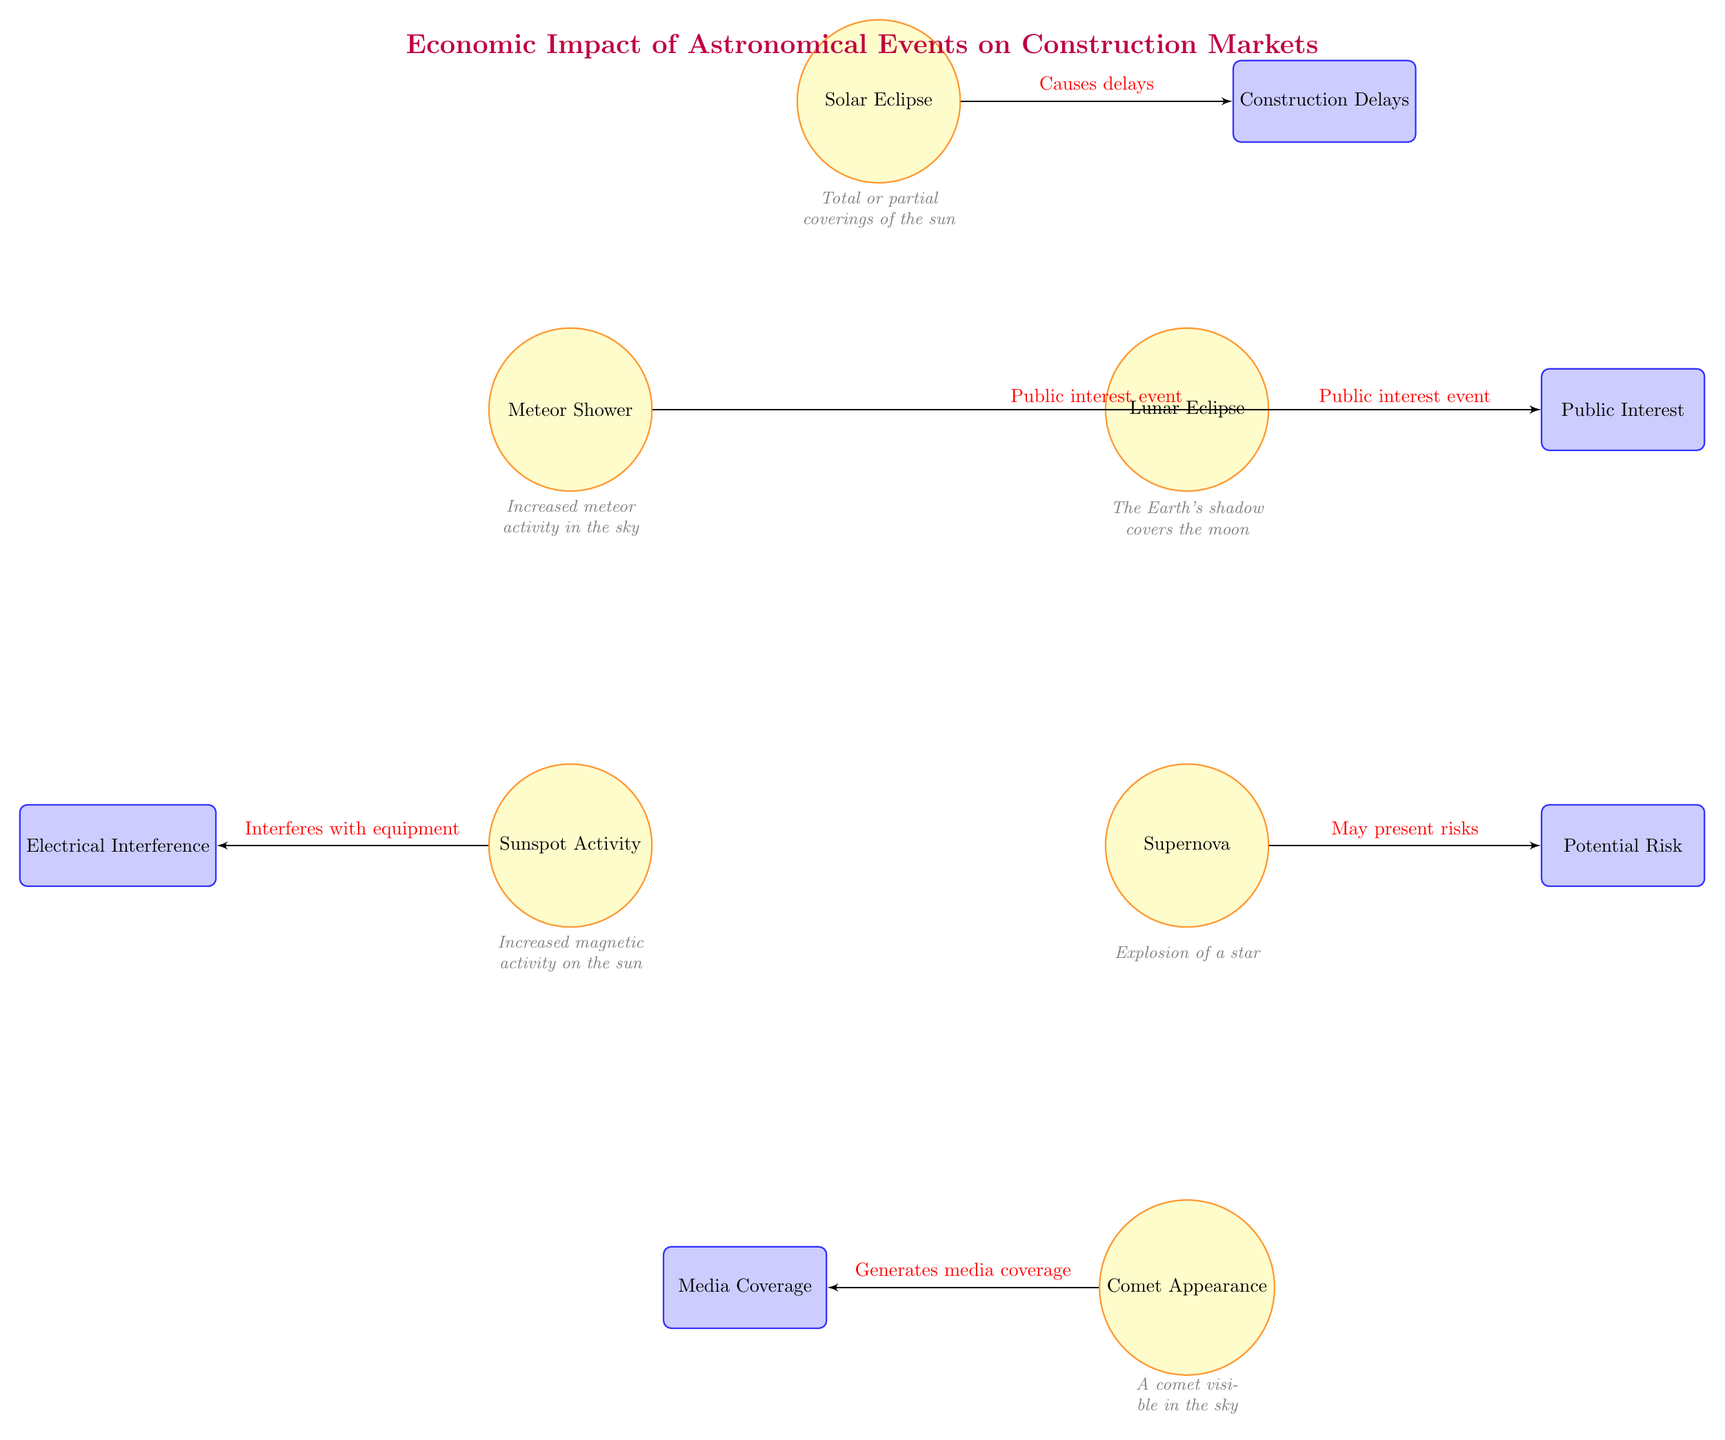What astronomical event is associated with construction delays? The diagram indicates that a Solar Eclipse causes delays related to construction. Connecting the Solar Eclipse node to the Construction Delays node reveals this relationship.
Answer: Solar Eclipse How many events are shown in the diagram? By counting the event nodes (Solar Eclipse, Lunar Eclipse, Meteor Shower, Supernova, Sunspot Activity, Comet Appearance), there are a total of six events represented in the diagram.
Answer: 6 Which event is linked to potential risk? The diagram shows that the Supernova is linked with potential risks in the construction sector, as indicated by the flow from the Supernova node to the Potential Risk node.
Answer: Supernova What effect does sunspot activity have on construction? The diagram specifies that sunspot activity interferes with equipment, which is directly noted by the connection from the Sunspot Activity node to the Electrical Interference node.
Answer: Interferes with equipment Which two events are categorized as public interest events? The diagram indicates that both the Lunar Eclipse and Meteor Shower are public interest events, as they point to the Public Interest node from each respective event node.
Answer: Lunar Eclipse, Meteor Shower What is the primary relationship shown between the solar eclipse and construction? The connection from the Solar Eclipse node to the Construction Delays node states that solar eclipses cause delays, serving as the main relationship depicted.
Answer: Causes delays Which astronomical event generates media coverage? According to the diagram, the Comet Appearance is the event that generates media coverage, leading to a link from the Comet Appearance node to the Media Coverage node.
Answer: Comet Appearance What is the main theme of the diagram? The title of the diagram clearly states that the main theme pertains to the "Economic Impact of Astronomical Events on Construction Markets," representing the overarching focus of the visual.
Answer: Economic Impact of Astronomical Events on Construction Markets How many impacts are listed in the diagram? By examining the impact nodes (Construction Delays, Public Interest, Potential Risk, Electrical Interference, Media Coverage), there are a total of five impacts listed in the diagram.
Answer: 5 